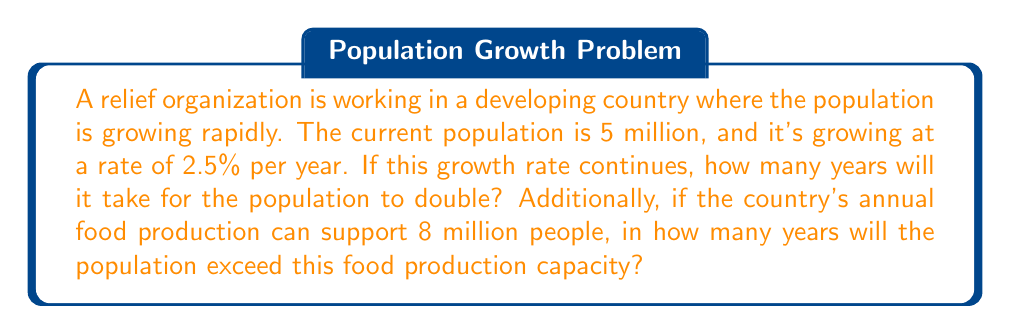Teach me how to tackle this problem. To solve this problem, we need to use the concept of exponential growth and the doubling time formula.

1. Calculating the doubling time:
The doubling time formula is:
$$ T = \frac{\ln(2)}{r} $$
Where $T$ is the doubling time and $r$ is the growth rate as a decimal.

In this case, $r = 0.025$ (2.5% = 0.025)

$$ T = \frac{\ln(2)}{0.025} \approx 27.73 \text{ years} $$

2. Calculating the time to exceed food production capacity:
We need to find $t$ in the equation:
$$ 5,000,000 \cdot (1 + 0.025)^t = 8,000,000 $$

Taking the natural log of both sides:
$$ \ln(8,000,000) = \ln(5,000,000) + t \cdot \ln(1.025) $$

Solving for $t$:
$$ t = \frac{\ln(8,000,000) - \ln(5,000,000)}{\ln(1.025)} \approx 19.27 \text{ years} $$

Therefore, it will take approximately 19.27 years for the population to exceed the food production capacity.
Answer: The population will double in approximately 27.73 years, and it will exceed the food production capacity in approximately 19.27 years. 